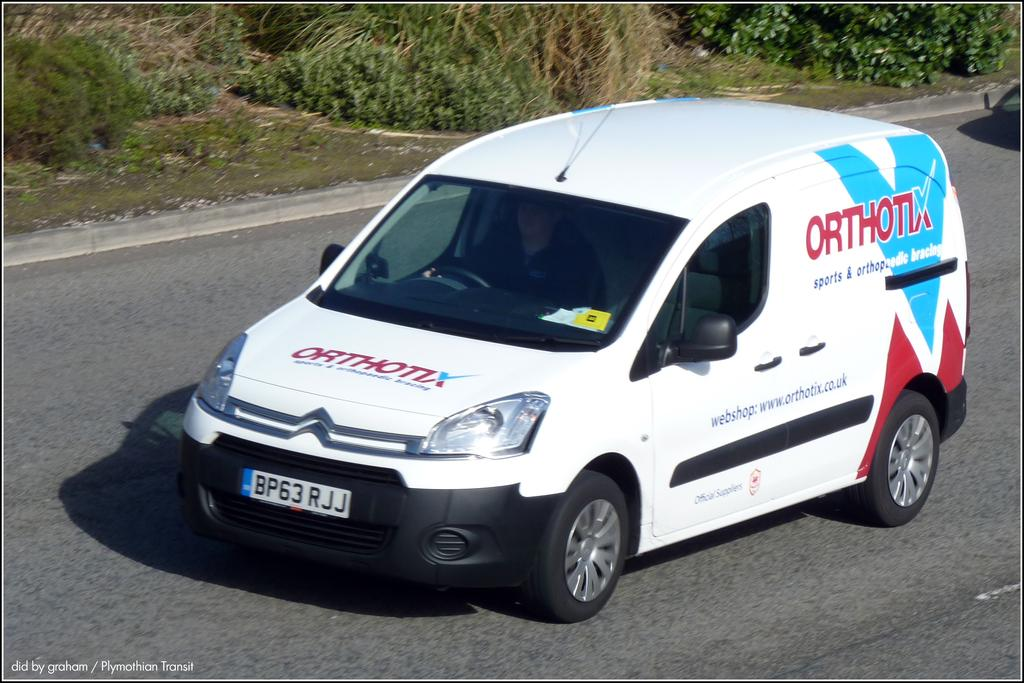What color is the car in the image? The car in the image is white. What is the car doing in the image? The car is moving on a road. What can be seen in the background of the image? There are plants in the background of the image. What type of fruit is hanging from the cactus in the image? There is no cactus or fruit present in the image; it features a white color car moving on a road with plants in the background. 